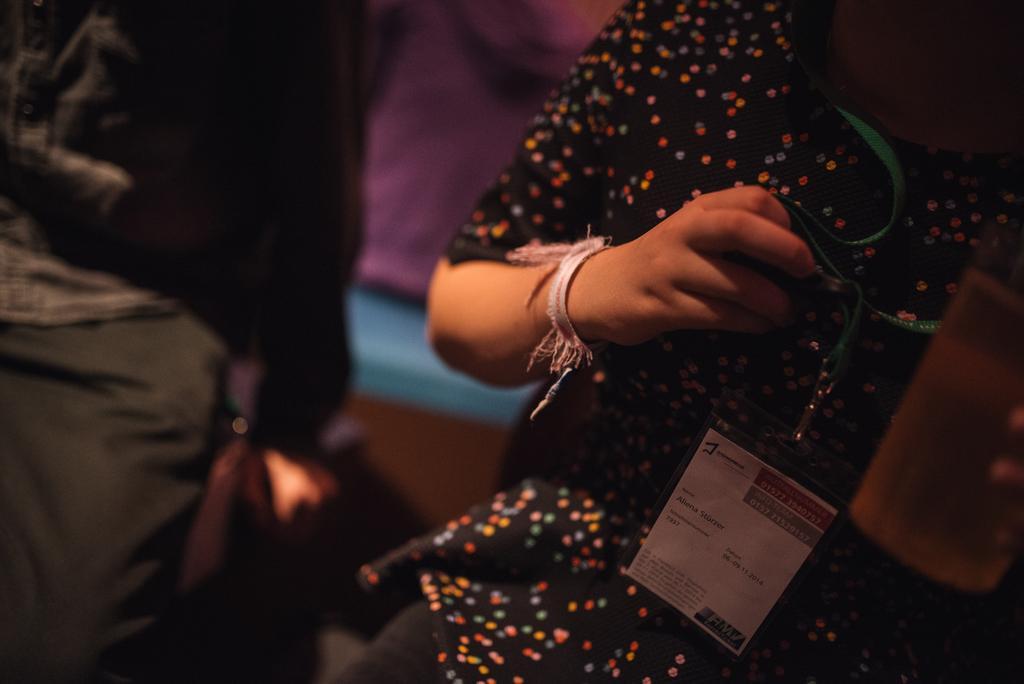Describe this image in one or two sentences. In this image, we can see a person holding id card and a glass and there are some other people in the background. 